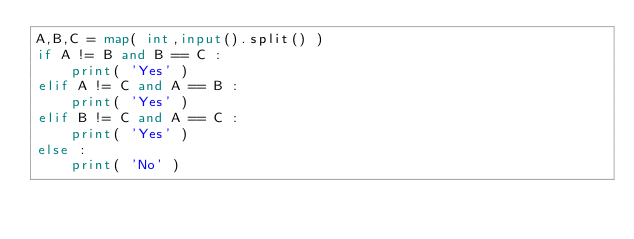Convert code to text. <code><loc_0><loc_0><loc_500><loc_500><_Python_>A,B,C = map( int,input().split() )
if A != B and B == C :
    print( 'Yes' )
elif A != C and A == B :
    print( 'Yes' )
elif B != C and A == C :
    print( 'Yes' )
else :
    print( 'No' )
    </code> 